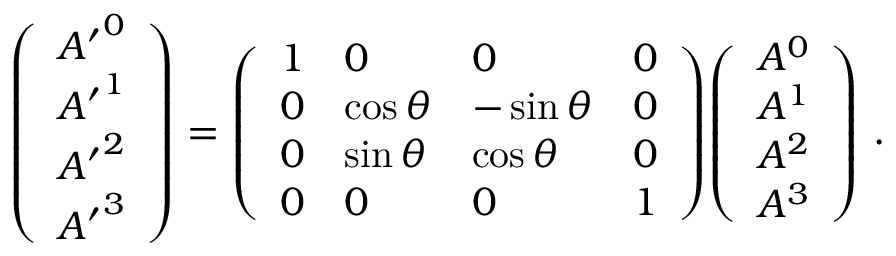<formula> <loc_0><loc_0><loc_500><loc_500>{ \left ( \begin{array} { l } { { A ^ { \prime } } ^ { 0 } } \\ { { A ^ { \prime } } ^ { 1 } } \\ { { A ^ { \prime } } ^ { 2 } } \\ { { A ^ { \prime } } ^ { 3 } } \end{array} \right ) } = { \left ( \begin{array} { l l l l } { 1 } & { 0 } & { 0 } & { 0 } \\ { 0 } & { \cos \theta } & { - \sin \theta } & { 0 } \\ { 0 } & { \sin \theta } & { \cos \theta } & { 0 } \\ { 0 } & { 0 } & { 0 } & { 1 } \end{array} \right ) } { \left ( \begin{array} { l } { A ^ { 0 } } \\ { A ^ { 1 } } \\ { A ^ { 2 } } \\ { A ^ { 3 } } \end{array} \right ) } \ .</formula> 